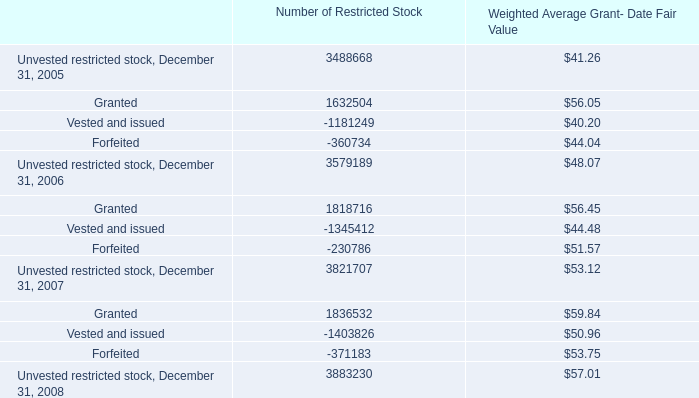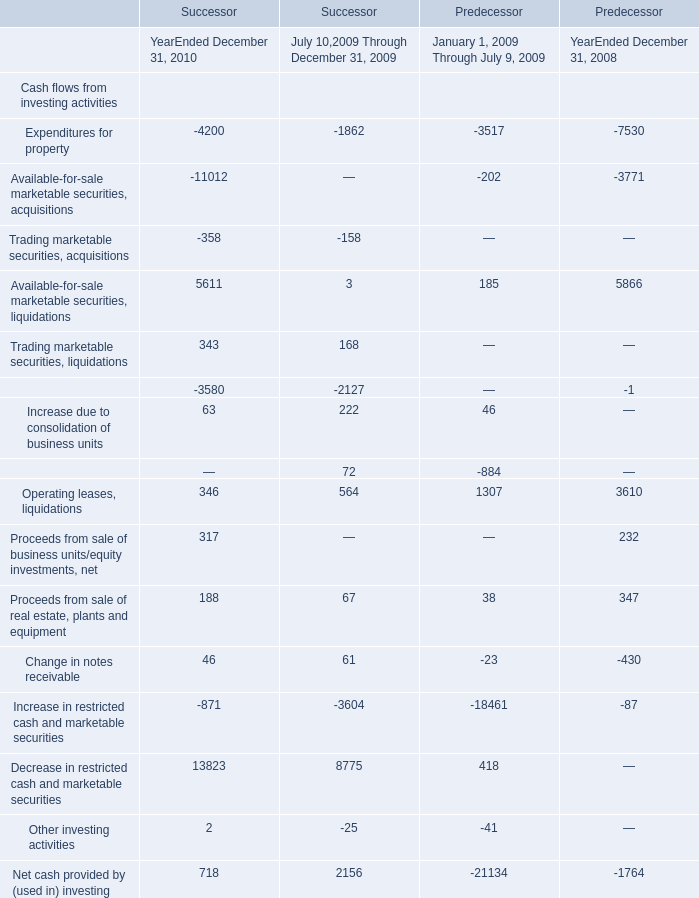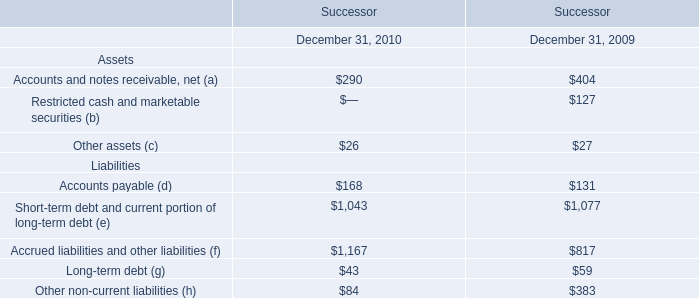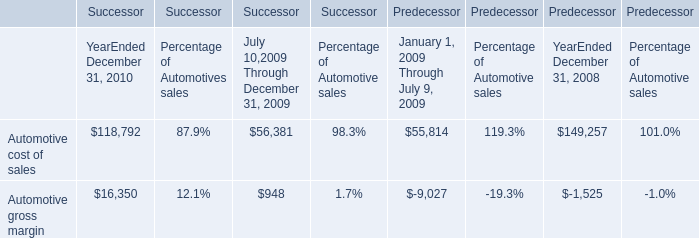What is the growing rate of Accounts payable (d) in Table 2 in the year with the most Automotive cost of sales for Successor in Table 3? 
Computations: ((168 - 131) / 131)
Answer: 0.28244. 